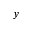<formula> <loc_0><loc_0><loc_500><loc_500>y</formula> 